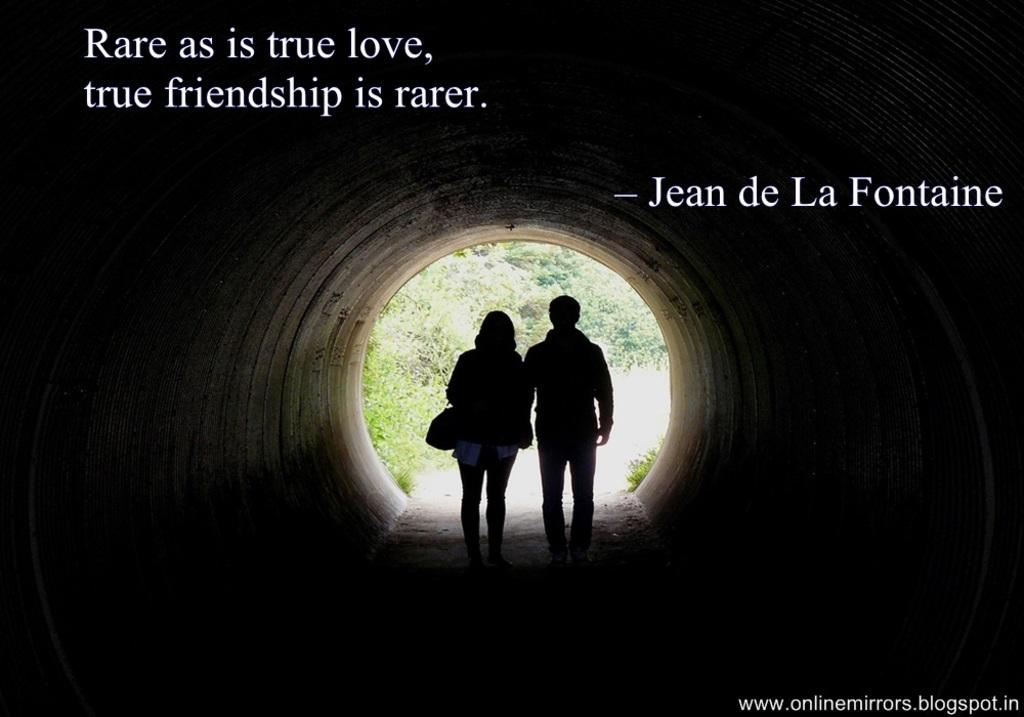How many people are in the image? There are two people in the image. Where are the people located in the image? The people are standing in a tunnel. What can be seen in front of the people? There are trees in front of the people. Can you describe any imperfections or marks on the image? Yes, there are watermarks on the image. What type of mist can be seen surrounding the horse in the image? There is no horse or mist present in the image; it features two people standing in a tunnel with trees in front of them. Can you describe the insect that is crawling on the person's shoulder in the image? There is no insect visible on the person's shoulder in the image. 